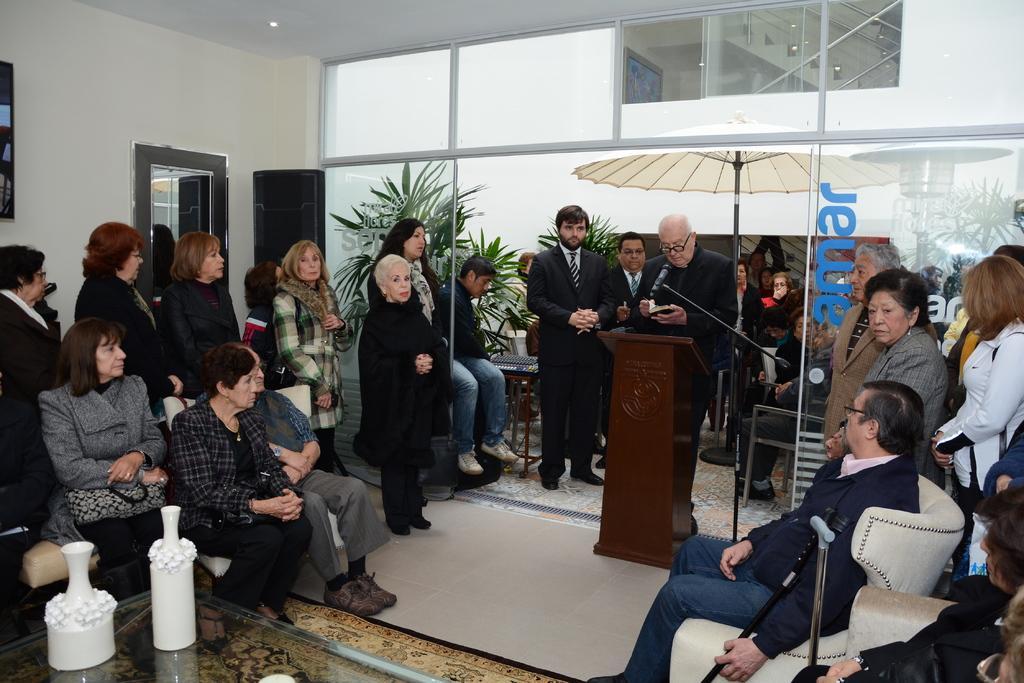Please provide a concise description of this image. In this image I can see few persons are sitting on couches and few persons are standing. I can see a person wearing black colored dress is standing behind the podium and I can see a microphone in front of him. In the background I can see the wall, the ceiling, a light to the ceiling, few plants, few persons and an umbrella. 